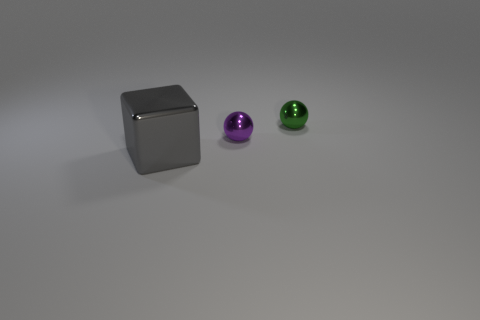Add 3 purple balls. How many objects exist? 6 Subtract all cubes. How many objects are left? 2 Add 1 small purple metal balls. How many small purple metal balls are left? 2 Add 3 large green metallic cylinders. How many large green metallic cylinders exist? 3 Subtract 0 blue balls. How many objects are left? 3 Subtract all small gray matte blocks. Subtract all shiny balls. How many objects are left? 1 